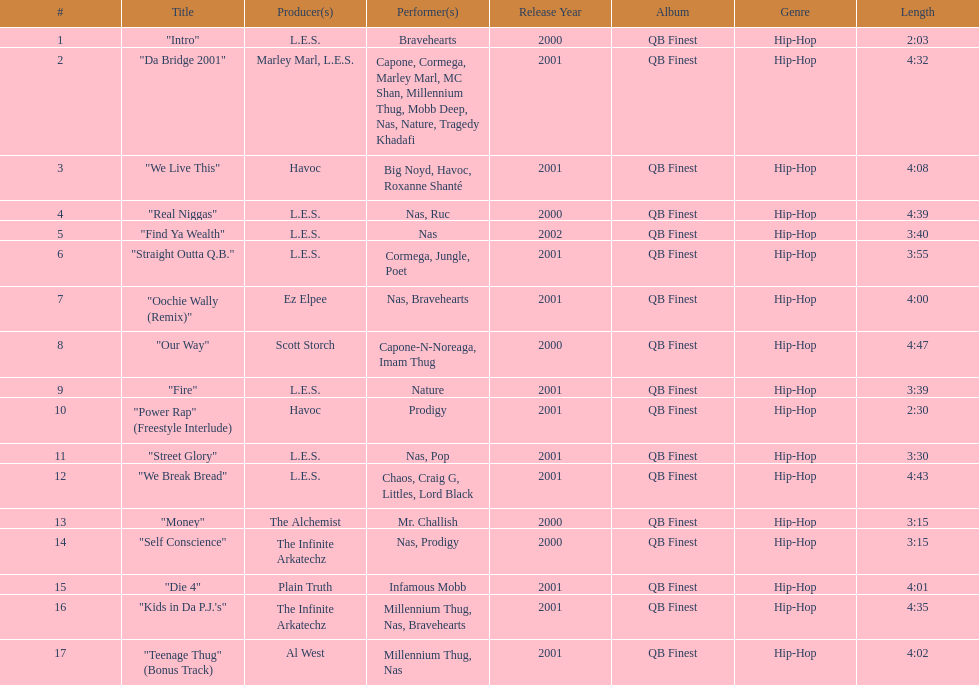Which artists were in the final track? Millennium Thug, Nas. 